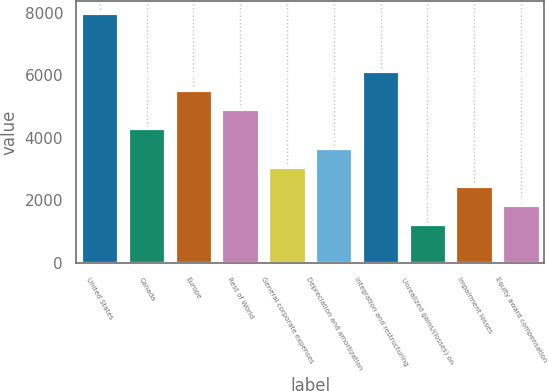Convert chart. <chart><loc_0><loc_0><loc_500><loc_500><bar_chart><fcel>United States<fcel>Canada<fcel>Europe<fcel>Rest of World<fcel>General corporate expenses<fcel>Depreciation and amortization<fcel>Integration and restructuring<fcel>Unrealized gains/(losses) on<fcel>Impairment losses<fcel>Equity award compensation<nl><fcel>7980.1<fcel>4303.9<fcel>5529.3<fcel>4916.6<fcel>3078.5<fcel>3691.2<fcel>6142<fcel>1240.4<fcel>2465.8<fcel>1853.1<nl></chart> 